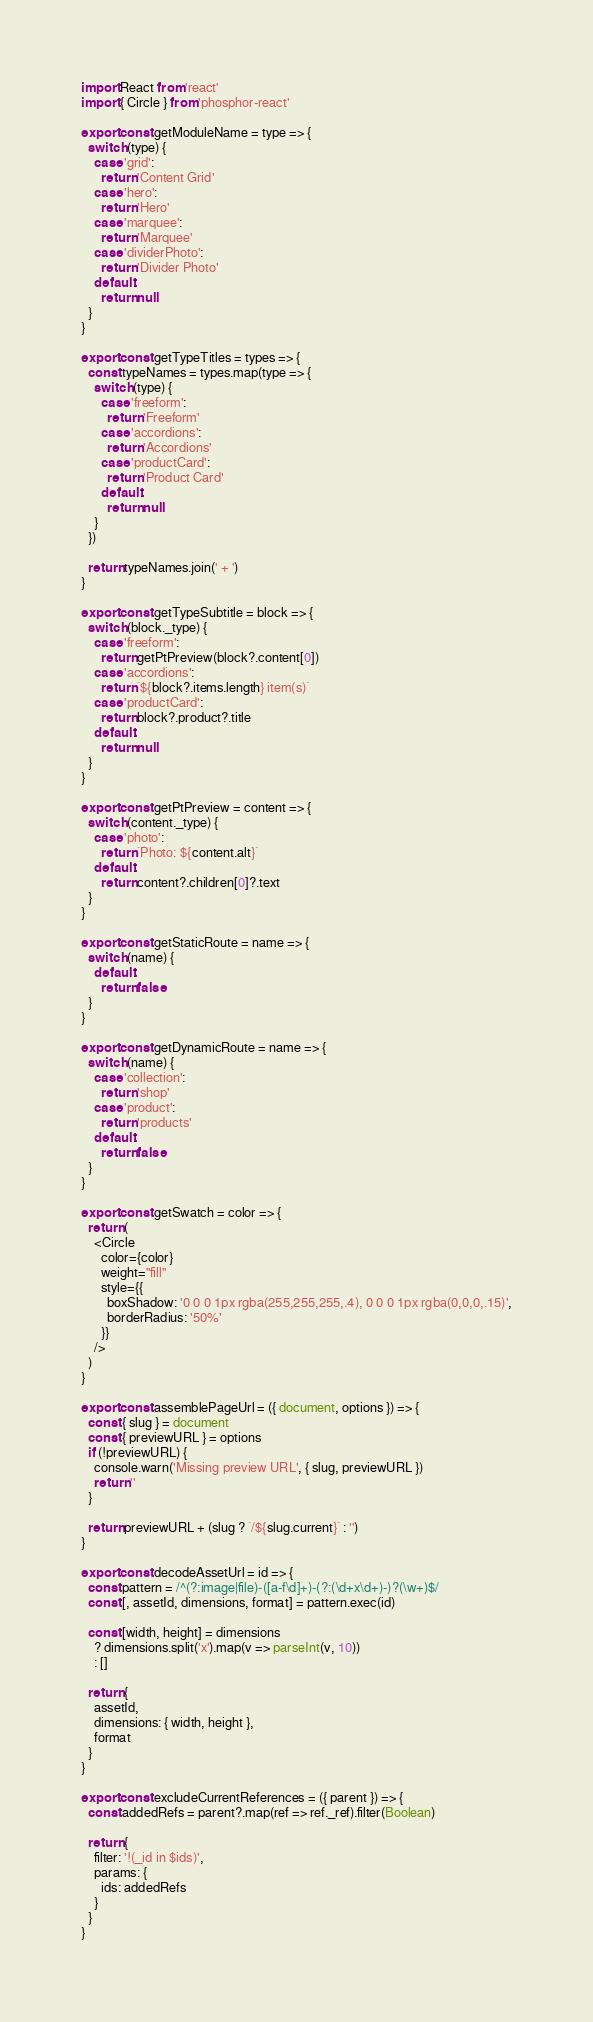<code> <loc_0><loc_0><loc_500><loc_500><_JavaScript_>import React from 'react'
import { Circle } from 'phosphor-react'

export const getModuleName = type => {
  switch (type) {
    case 'grid':
      return 'Content Grid'
    case 'hero':
      return 'Hero'
    case 'marquee':
      return 'Marquee'
    case 'dividerPhoto':
      return 'Divider Photo'
    default:
      return null
  }
}

export const getTypeTitles = types => {
  const typeNames = types.map(type => {
    switch (type) {
      case 'freeform':
        return 'Freeform'
      case 'accordions':
        return 'Accordions'
      case 'productCard':
        return 'Product Card'
      default:
        return null
    }
  })

  return typeNames.join(' + ')
}

export const getTypeSubtitle = block => {
  switch (block._type) {
    case 'freeform':
      return getPtPreview(block?.content[0])
    case 'accordions':
      return `${block?.items.length} item(s)`
    case 'productCard':
      return block?.product?.title
    default:
      return null
  }
}

export const getPtPreview = content => {
  switch (content._type) {
    case 'photo':
      return `Photo: ${content.alt}`
    default:
      return content?.children[0]?.text
  }
}

export const getStaticRoute = name => {
  switch (name) {
    default:
      return false
  }
}

export const getDynamicRoute = name => {
  switch (name) {
    case 'collection':
      return 'shop'
    case 'product':
      return 'products'
    default:
      return false
  }
}

export const getSwatch = color => {
  return (
    <Circle
      color={color}
      weight="fill"
      style={{
        boxShadow: '0 0 0 1px rgba(255,255,255,.4), 0 0 0 1px rgba(0,0,0,.15)',
        borderRadius: '50%'
      }}
    />
  )
}

export const assemblePageUrl = ({ document, options }) => {
  const { slug } = document
  const { previewURL } = options
  if (!previewURL) {
    console.warn('Missing preview URL', { slug, previewURL })
    return ''
  }

  return previewURL + (slug ? `/${slug.current}` : '')
}

export const decodeAssetUrl = id => {
  const pattern = /^(?:image|file)-([a-f\d]+)-(?:(\d+x\d+)-)?(\w+)$/
  const [, assetId, dimensions, format] = pattern.exec(id)

  const [width, height] = dimensions
    ? dimensions.split('x').map(v => parseInt(v, 10))
    : []

  return {
    assetId,
    dimensions: { width, height },
    format
  }
}

export const excludeCurrentReferences = ({ parent }) => {
  const addedRefs = parent?.map(ref => ref._ref).filter(Boolean)

  return {
    filter: '!(_id in $ids)',
    params: {
      ids: addedRefs
    }
  }
}
</code> 